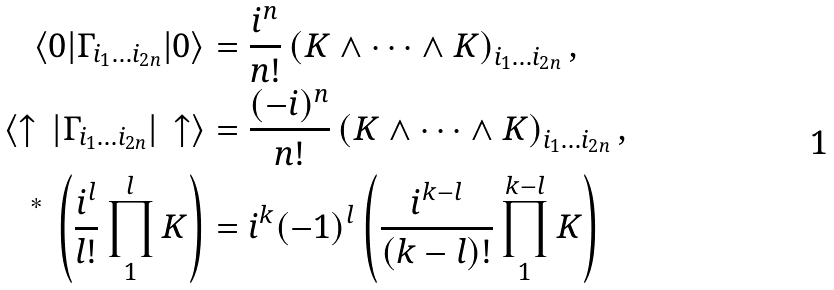Convert formula to latex. <formula><loc_0><loc_0><loc_500><loc_500>\langle 0 | \Gamma _ { i _ { 1 } \dots i _ { 2 n } } | 0 \rangle & = \frac { i ^ { n } } { n ! } \left ( K \wedge \cdots \wedge K \right ) _ { i _ { 1 } \dots i _ { 2 n } } , \\ \langle \uparrow \, | \Gamma _ { i _ { 1 } \dots i _ { 2 n } } | \, \uparrow \rangle & = \frac { ( - i ) ^ { n } } { n ! } \left ( K \wedge \cdots \wedge K \right ) _ { i _ { 1 } \dots i _ { 2 n } } , \\ { \Big . } ^ { * } \, \left ( \frac { i ^ { l } } { l ! } \prod _ { 1 } ^ { l } K \right ) & = i ^ { k } ( - 1 ) ^ { l } \left ( \frac { i ^ { k - l } } { ( k - l ) ! } \prod _ { 1 } ^ { k - l } K \right )</formula> 